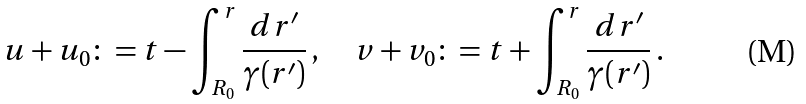Convert formula to latex. <formula><loc_0><loc_0><loc_500><loc_500>u + u _ { 0 } \colon = t - \int ^ { r } _ { R _ { 0 } } \frac { d r ^ { \prime } } { \gamma ( r ^ { \prime } ) } \, , \quad v + v _ { 0 } \colon = t + \int ^ { r } _ { R _ { 0 } } \frac { d r ^ { \prime } } { \gamma ( r ^ { \prime } ) } \, .</formula> 